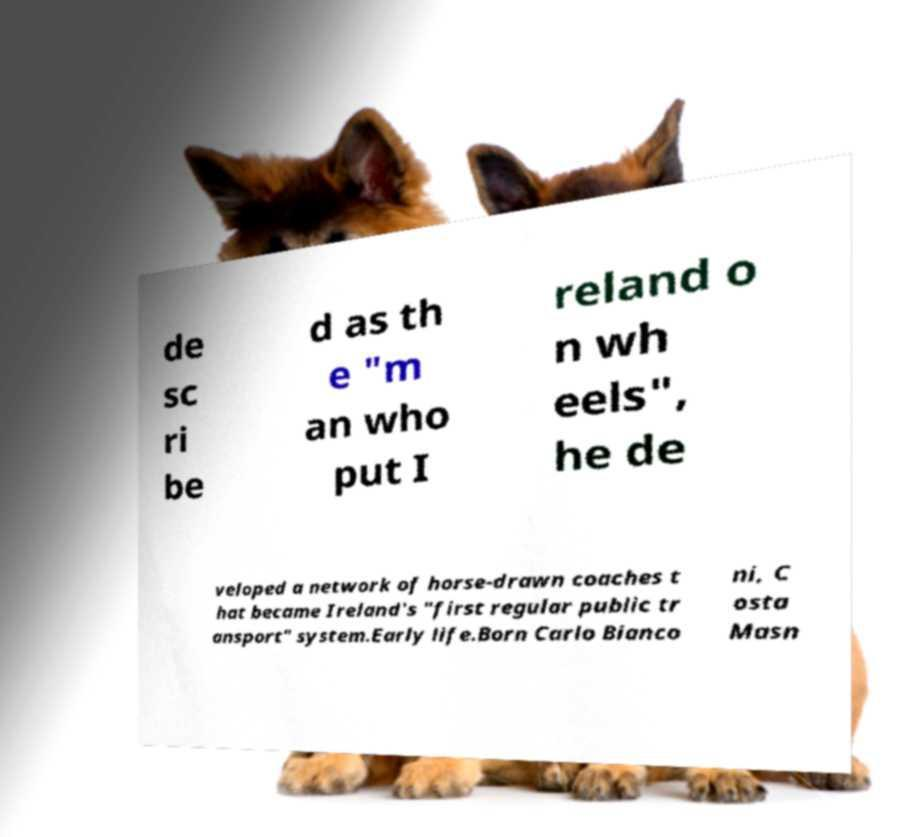Can you accurately transcribe the text from the provided image for me? de sc ri be d as th e "m an who put I reland o n wh eels", he de veloped a network of horse-drawn coaches t hat became Ireland's "first regular public tr ansport" system.Early life.Born Carlo Bianco ni, C osta Masn 